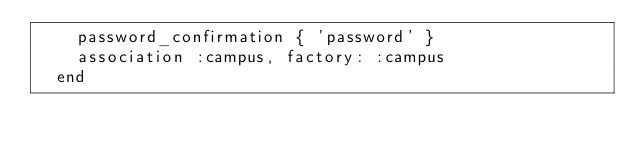<code> <loc_0><loc_0><loc_500><loc_500><_Ruby_>    password_confirmation { 'password' }
    association :campus, factory: :campus
  end
</code> 